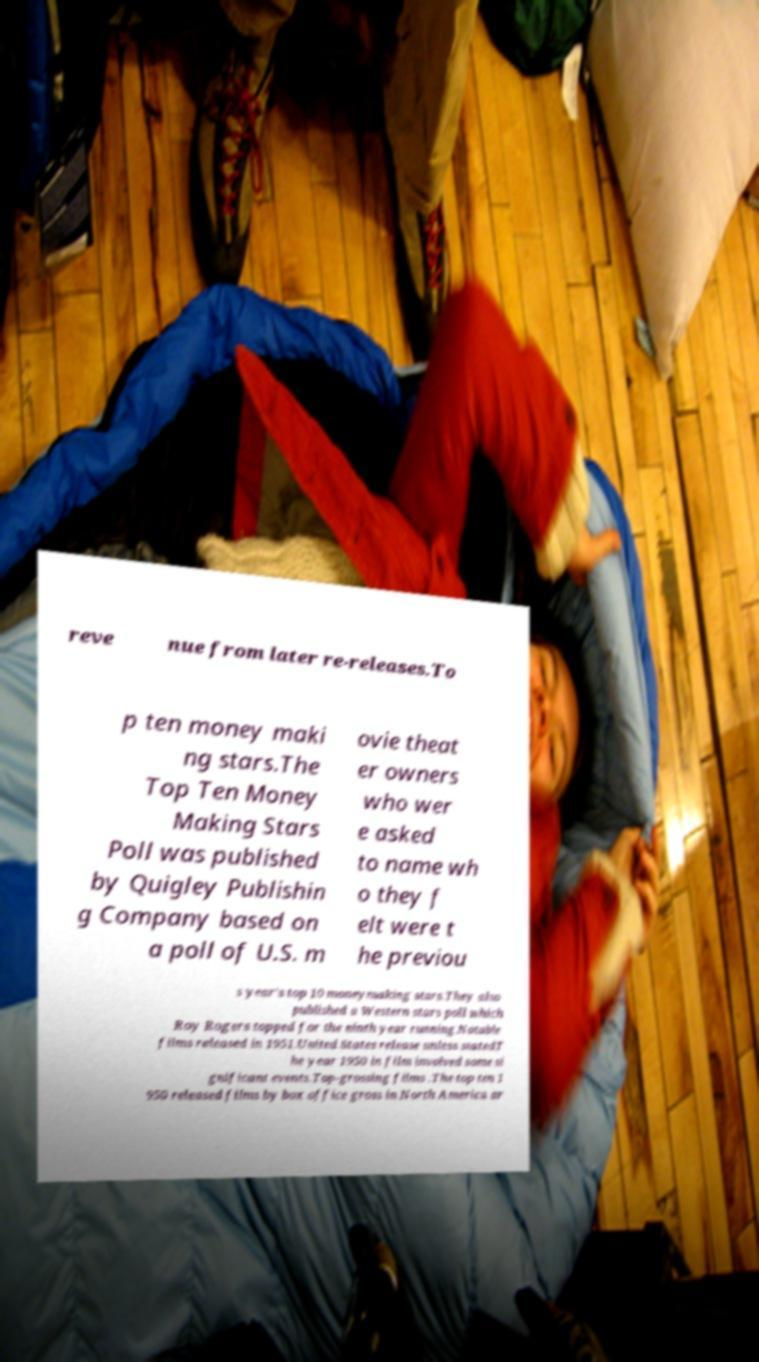Please identify and transcribe the text found in this image. reve nue from later re-releases.To p ten money maki ng stars.The Top Ten Money Making Stars Poll was published by Quigley Publishin g Company based on a poll of U.S. m ovie theat er owners who wer e asked to name wh o they f elt were t he previou s year's top 10 moneymaking stars.They also published a Western stars poll which Roy Rogers topped for the ninth year running.Notable films released in 1951.United States release unless statedT he year 1950 in film involved some si gnificant events.Top-grossing films .The top ten 1 950 released films by box office gross in North America ar 